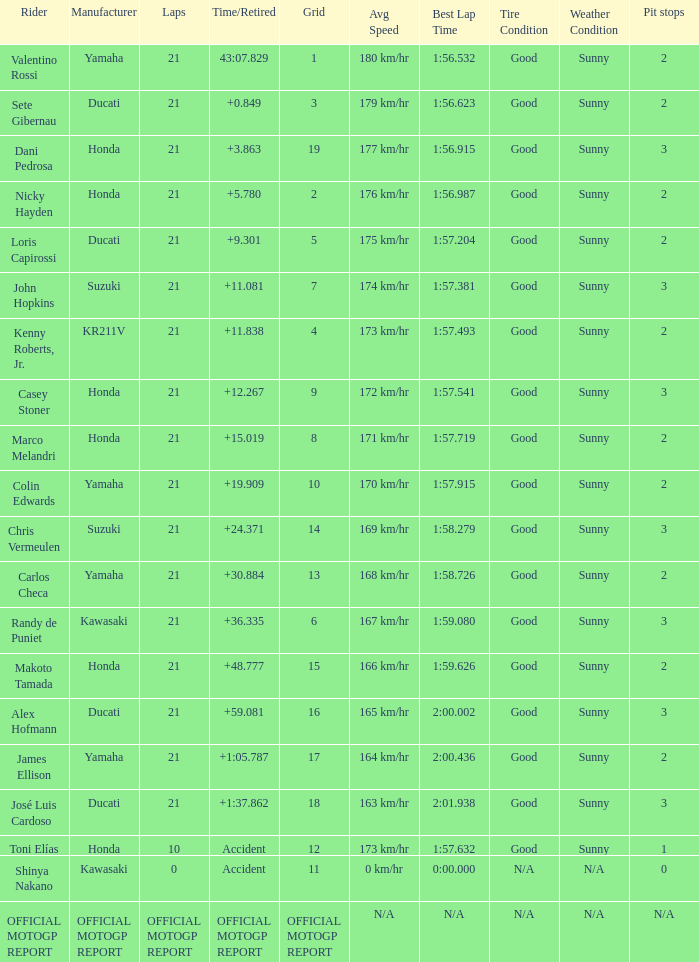What is the time/retired for the rider with the manufacturuer yamaha, grod of 1 and 21 total laps? 43:07.829. Can you parse all the data within this table? {'header': ['Rider', 'Manufacturer', 'Laps', 'Time/Retired', 'Grid', 'Avg Speed', 'Best Lap Time', 'Tire Condition', 'Weather Condition', 'Pit stops'], 'rows': [['Valentino Rossi', 'Yamaha', '21', '43:07.829', '1', '180 km/hr', '1:56.532', 'Good', 'Sunny', '2'], ['Sete Gibernau', 'Ducati', '21', '+0.849', '3', '179 km/hr', '1:56.623', 'Good', 'Sunny', '2'], ['Dani Pedrosa', 'Honda', '21', '+3.863', '19', '177 km/hr', '1:56.915', 'Good', 'Sunny', '3'], ['Nicky Hayden', 'Honda', '21', '+5.780', '2', '176 km/hr', '1:56.987', 'Good', 'Sunny', '2'], ['Loris Capirossi', 'Ducati', '21', '+9.301', '5', '175 km/hr', '1:57.204', 'Good', 'Sunny', '2'], ['John Hopkins', 'Suzuki', '21', '+11.081', '7', '174 km/hr', '1:57.381', 'Good', 'Sunny', '3'], ['Kenny Roberts, Jr.', 'KR211V', '21', '+11.838', '4', '173 km/hr', '1:57.493', 'Good', 'Sunny', '2'], ['Casey Stoner', 'Honda', '21', '+12.267', '9', '172 km/hr', '1:57.541', 'Good', 'Sunny', '3'], ['Marco Melandri', 'Honda', '21', '+15.019', '8', '171 km/hr', '1:57.719', 'Good', 'Sunny', '2'], ['Colin Edwards', 'Yamaha', '21', '+19.909', '10', '170 km/hr', '1:57.915', 'Good', 'Sunny', '2'], ['Chris Vermeulen', 'Suzuki', '21', '+24.371', '14', '169 km/hr', '1:58.279', 'Good', 'Sunny', '3'], ['Carlos Checa', 'Yamaha', '21', '+30.884', '13', '168 km/hr', '1:58.726', 'Good', 'Sunny', '2'], ['Randy de Puniet', 'Kawasaki', '21', '+36.335', '6', '167 km/hr', '1:59.080', 'Good', 'Sunny', '3'], ['Makoto Tamada', 'Honda', '21', '+48.777', '15', '166 km/hr', '1:59.626', 'Good', 'Sunny', '2'], ['Alex Hofmann', 'Ducati', '21', '+59.081', '16', '165 km/hr', '2:00.002', 'Good', 'Sunny', '3'], ['James Ellison', 'Yamaha', '21', '+1:05.787', '17', '164 km/hr', '2:00.436', 'Good', 'Sunny', '2'], ['José Luis Cardoso', 'Ducati', '21', '+1:37.862', '18', '163 km/hr', '2:01.938', 'Good', 'Sunny', '3'], ['Toni Elías', 'Honda', '10', 'Accident', '12', '173 km/hr', '1:57.632', 'Good', 'Sunny', '1'], ['Shinya Nakano', 'Kawasaki', '0', 'Accident', '11', '0 km/hr', '0:00.000', 'N/A', 'N/A', '0'], ['OFFICIAL MOTOGP REPORT', 'OFFICIAL MOTOGP REPORT', 'OFFICIAL MOTOGP REPORT', 'OFFICIAL MOTOGP REPORT', 'OFFICIAL MOTOGP REPORT', 'N/A', 'N/A', 'N/A', 'N/A', 'N/A']]} 